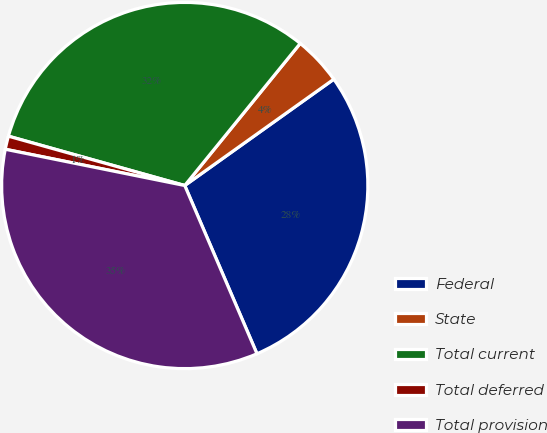Convert chart. <chart><loc_0><loc_0><loc_500><loc_500><pie_chart><fcel>Federal<fcel>State<fcel>Total current<fcel>Total deferred<fcel>Total provision<nl><fcel>28.41%<fcel>4.28%<fcel>31.52%<fcel>1.17%<fcel>34.63%<nl></chart> 